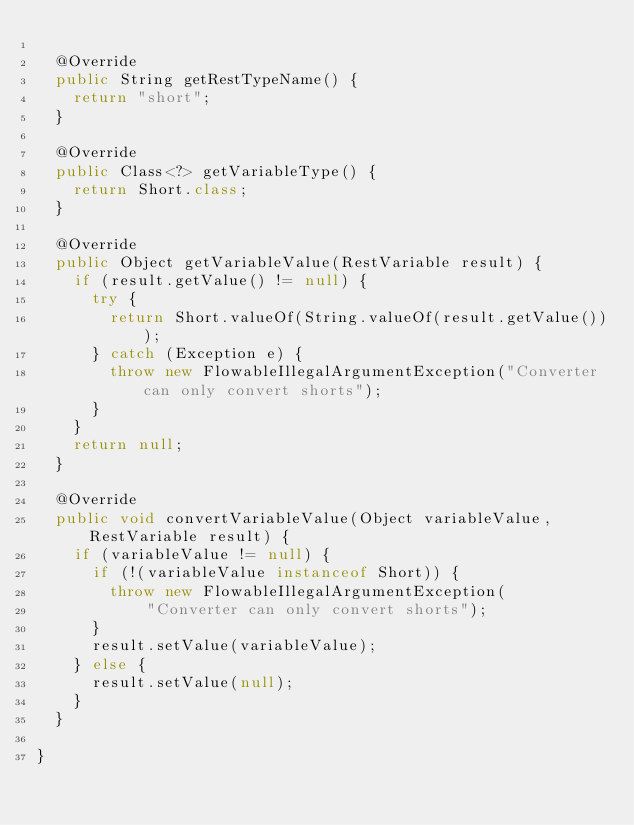<code> <loc_0><loc_0><loc_500><loc_500><_Java_>
	@Override
	public String getRestTypeName() {
		return "short";
	}

	@Override
	public Class<?> getVariableType() {
		return Short.class;
	}

	@Override
	public Object getVariableValue(RestVariable result) {
		if (result.getValue() != null) {
			try {
				return Short.valueOf(String.valueOf(result.getValue()));
			} catch (Exception e) {
				throw new FlowableIllegalArgumentException("Converter can only convert shorts");
			}
		}
		return null;
	}

	@Override
	public void convertVariableValue(Object variableValue, RestVariable result) {
		if (variableValue != null) {
			if (!(variableValue instanceof Short)) {
				throw new FlowableIllegalArgumentException(
						"Converter can only convert shorts");
			}
			result.setValue(variableValue);
		} else {
			result.setValue(null);
		}
	}

}
</code> 